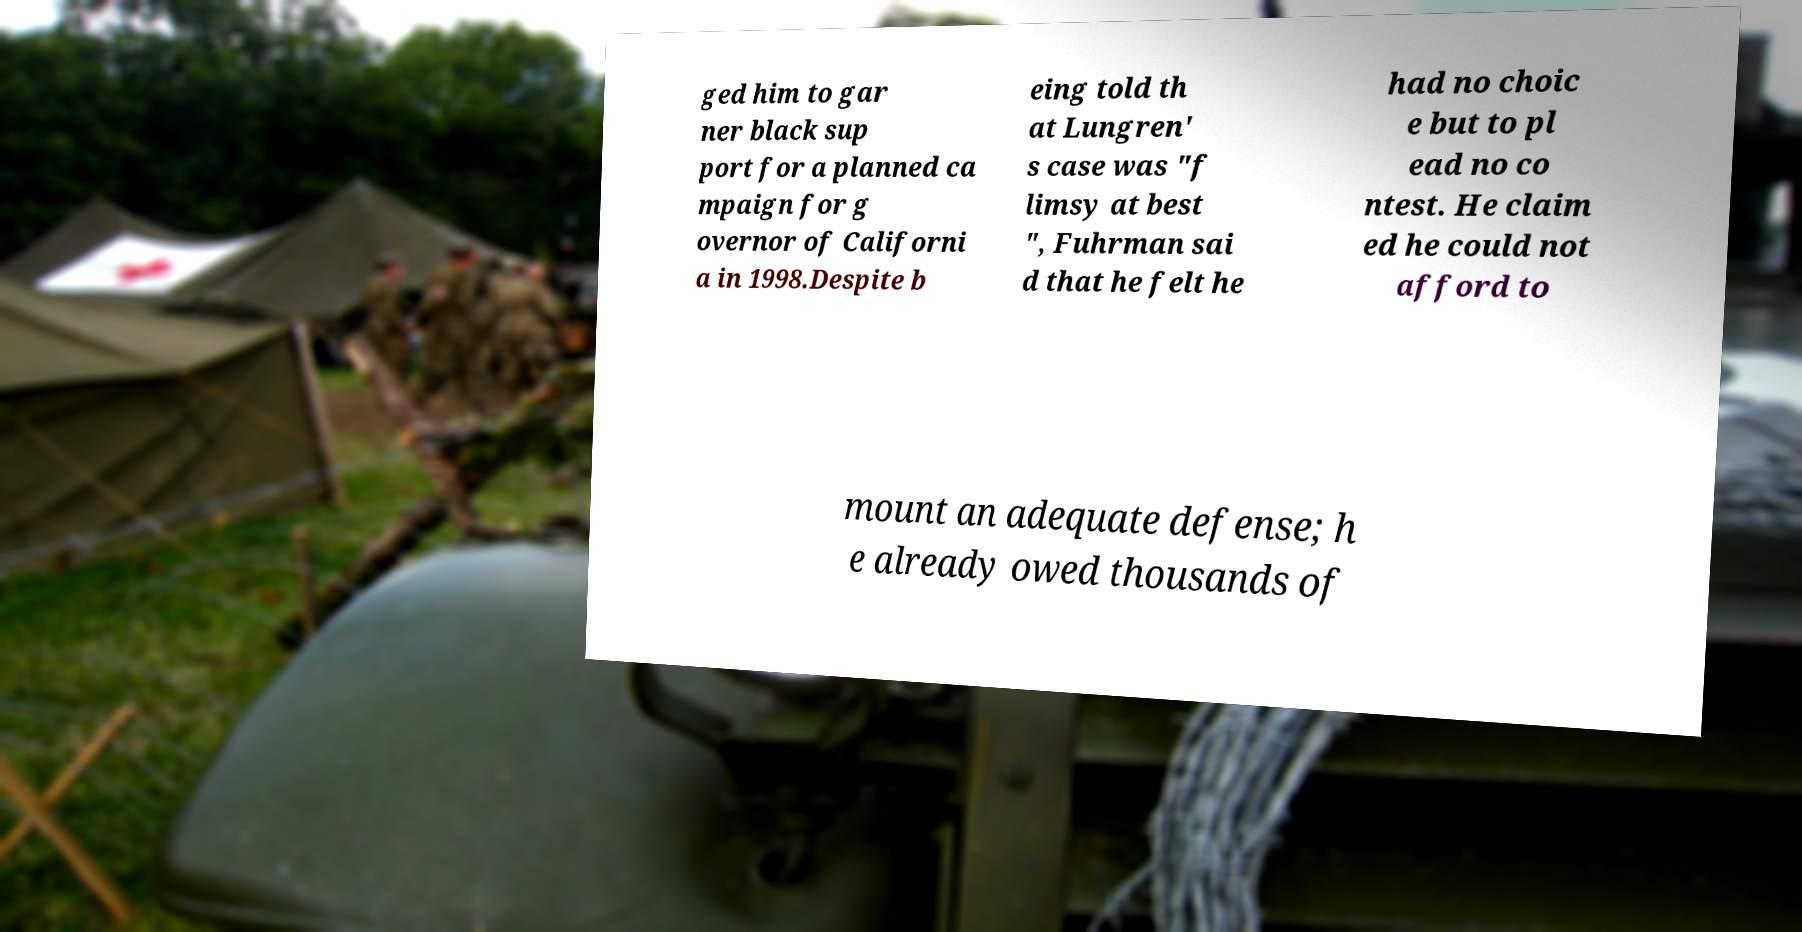For documentation purposes, I need the text within this image transcribed. Could you provide that? ged him to gar ner black sup port for a planned ca mpaign for g overnor of Californi a in 1998.Despite b eing told th at Lungren' s case was "f limsy at best ", Fuhrman sai d that he felt he had no choic e but to pl ead no co ntest. He claim ed he could not afford to mount an adequate defense; h e already owed thousands of 